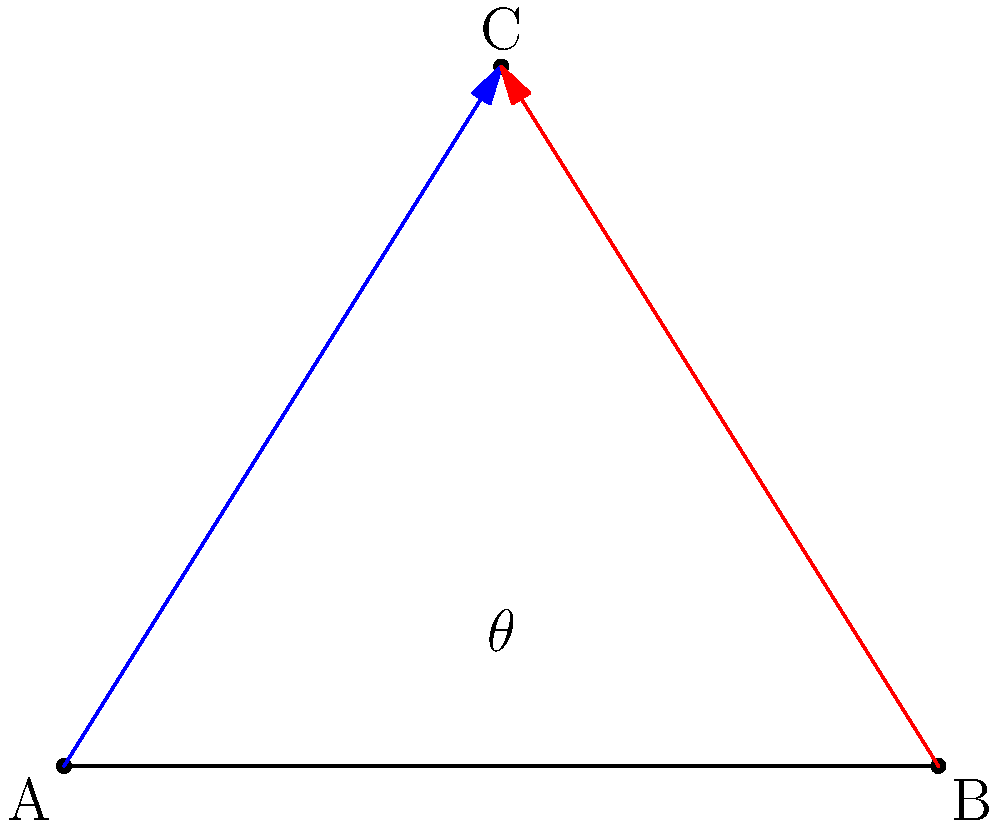In a pivotal scene from "Your Name", Taki and Mitsuha's sightlines intersect at point C. If Taki is positioned at point A(0,0) and Mitsuha at point B(5,0), and their gazes meet at point C(2.5,4), what is the angle $\theta$ between their sightlines? (Round your answer to the nearest degree.) To find the angle between the two sightlines, we can follow these steps:

1) First, we need to calculate the lengths of AC and BC using the distance formula:

   $AC = \sqrt{(2.5-0)^2 + (4-0)^2} = \sqrt{6.25 + 16} = \sqrt{22.25} = 4.7169$
   $BC = \sqrt{(2.5-5)^2 + (4-0)^2} = \sqrt{6.25 + 16} = \sqrt{22.25} = 4.7169$

2) Now we know all three sides of the triangle ABC. We can use the law of cosines to find the angle $\theta$:

   $c^2 = a^2 + b^2 - 2ab \cos(\theta)$

   Where $c$ is the length of AB (which is 5), and $a$ and $b$ are the lengths of AC and BC respectively.

3) Plugging in the values:

   $5^2 = 4.7169^2 + 4.7169^2 - 2(4.7169)(4.7169)\cos(\theta)$

4) Simplifying:

   $25 = 44.5 - 44.5\cos(\theta)$

5) Solving for $\cos(\theta)$:

   $44.5\cos(\theta) = 44.5 - 25 = 19.5$
   $\cos(\theta) = \frac{19.5}{44.5} = 0.4382$

6) Taking the inverse cosine (arccos) of both sides:

   $\theta = \arccos(0.4382) = 1.1071$ radians

7) Converting to degrees:

   $\theta = 1.1071 \times \frac{180}{\pi} = 63.43°$

8) Rounding to the nearest degree:

   $\theta \approx 63°$
Answer: $63°$ 